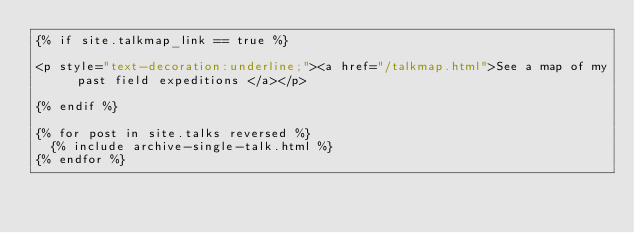<code> <loc_0><loc_0><loc_500><loc_500><_HTML_>{% if site.talkmap_link == true %}

<p style="text-decoration:underline;"><a href="/talkmap.html">See a map of my past field expeditions </a></p>

{% endif %}

{% for post in site.talks reversed %}
  {% include archive-single-talk.html %}
{% endfor %}
</code> 